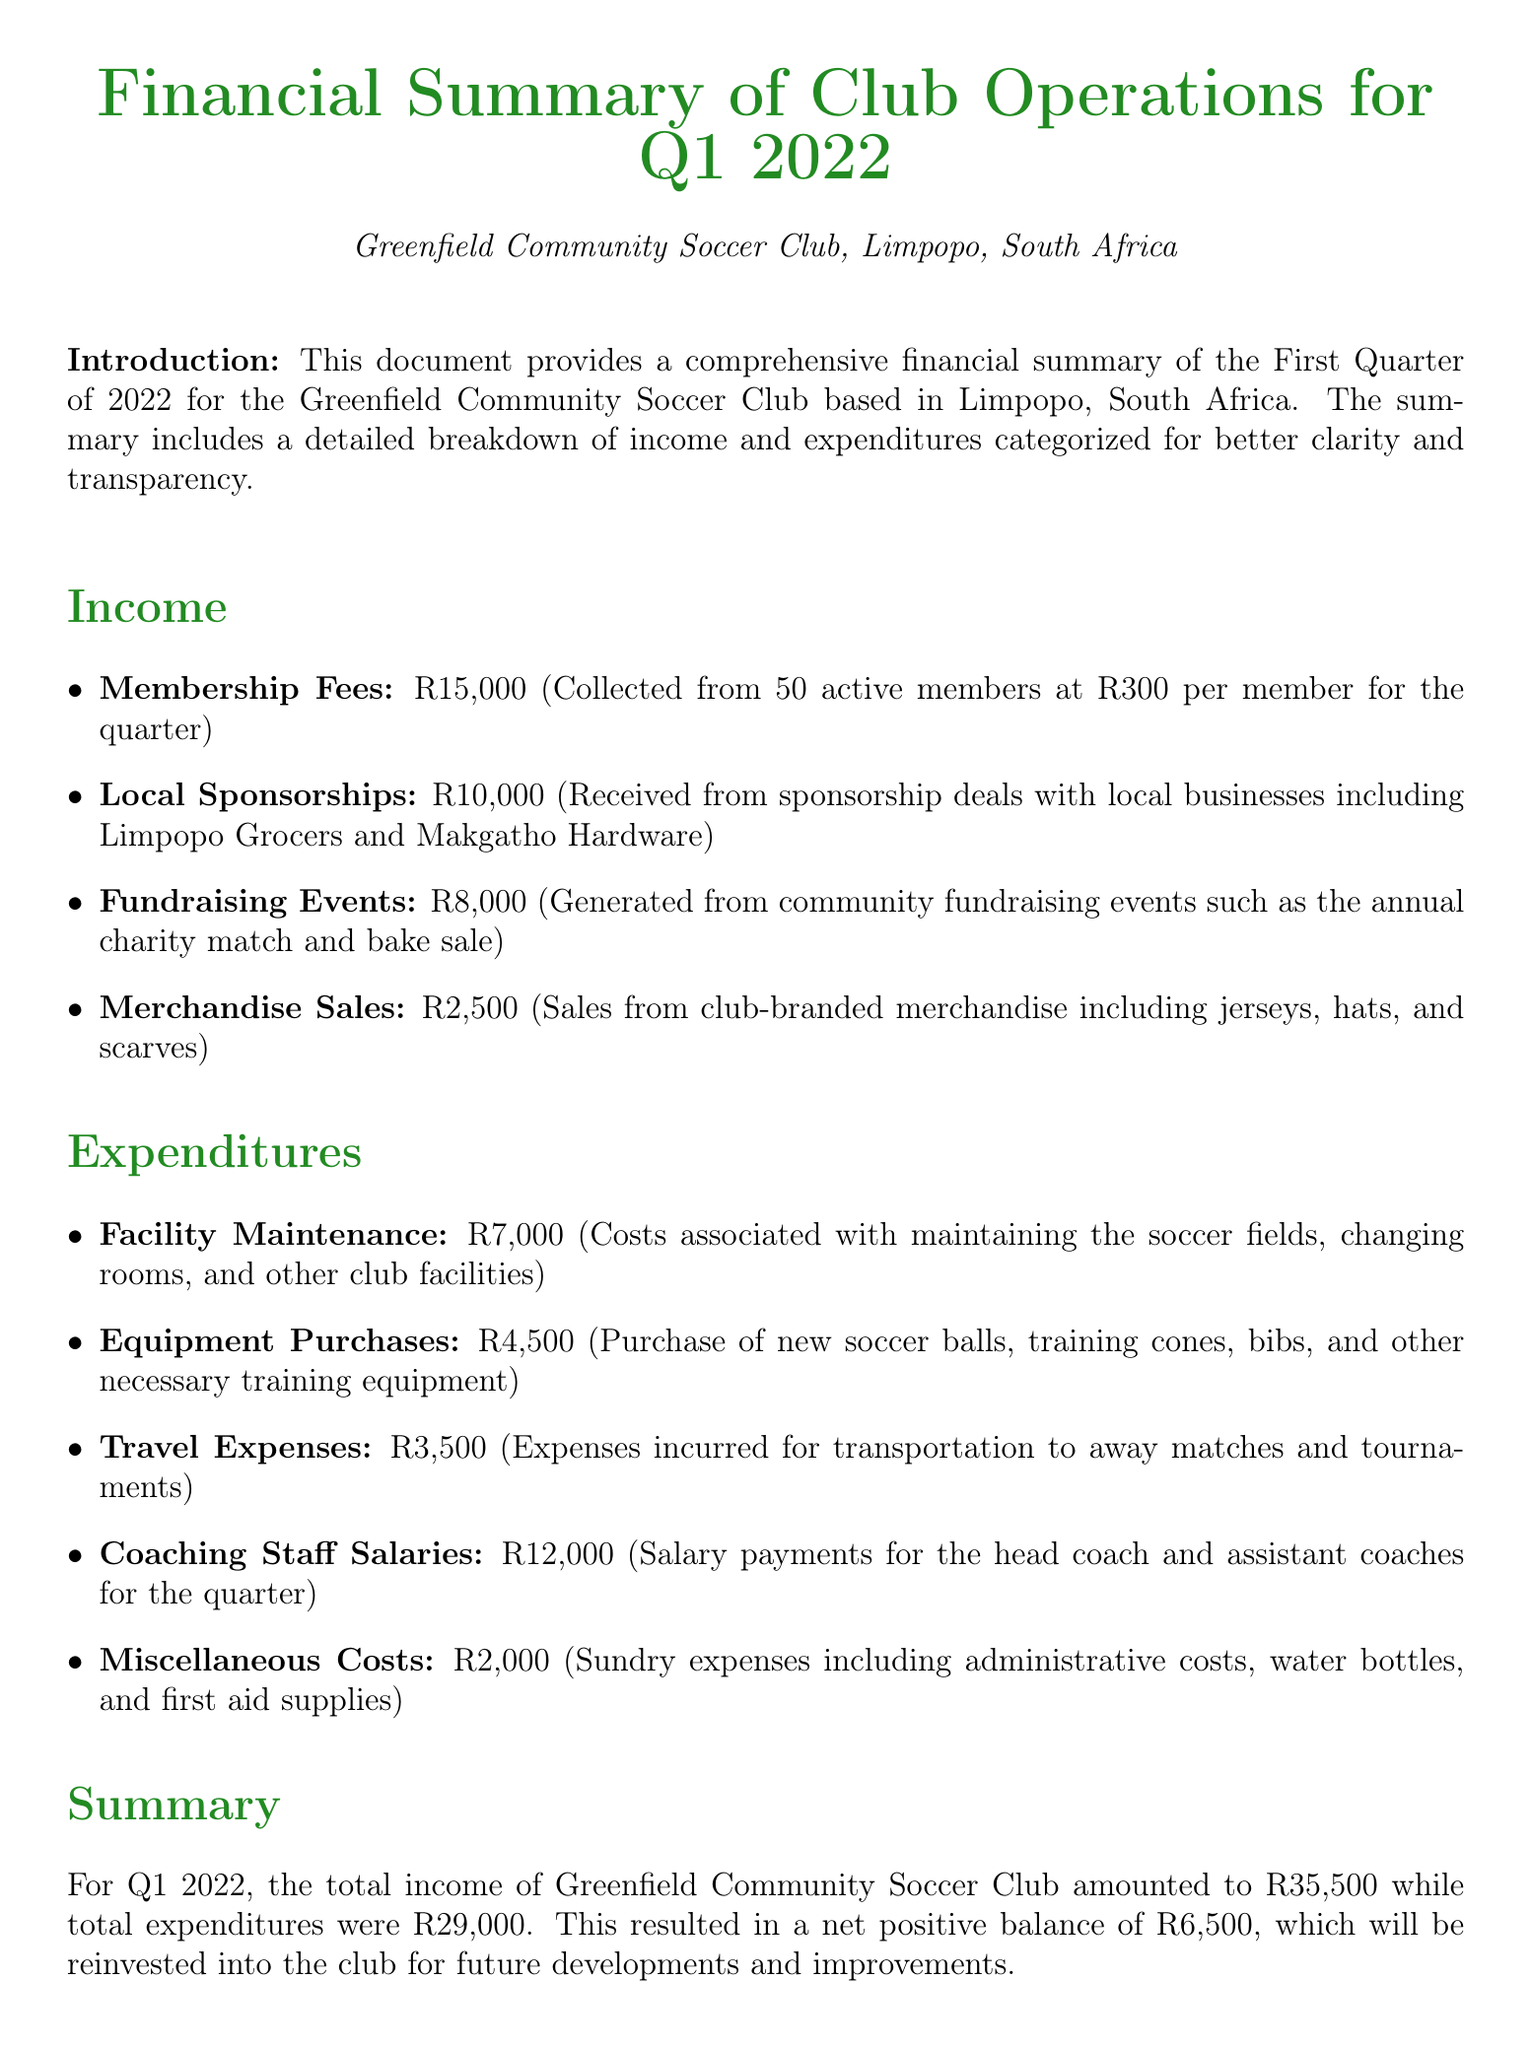What is the total income? The total income is stated in the summary section, combining all income sources, which is R15,000 + R10,000 + R8,000 + R2,500 = R35,500.
Answer: R35,500 What was spent on coaching staff salaries? The document includes a specific expenditure item for coaching staff salaries, which is mentioned as R12,000.
Answer: R12,000 How many members contributed to the membership fees? The membership fees section states that fees were collected from 50 active members.
Answer: 50 What is the total expenditure for Q1 2022? The total expenditure is the sum of all expenditure items listed in the document, which totals R29,000.
Answer: R29,000 What is the net positive balance for the quarter? The summary calculates the net positive balance by subtracting total expenditures from total income, which is R35,500 - R29,000 = R6,500.
Answer: R6,500 How much was raised from fundraising events? The income section specifies that R8,000 was generated from community fundraising events.
Answer: R8,000 What is the total amount spent on facility maintenance? The expenditures include a line item for facility maintenance, which is R7,000.
Answer: R7,000 How many categories are listed under Income? The income section outlines four distinct categories of income.
Answer: Four What is the document's purpose? The introduction outlines that the document provides a comprehensive financial summary of club operations, including income and expenditures.
Answer: Financial summary 